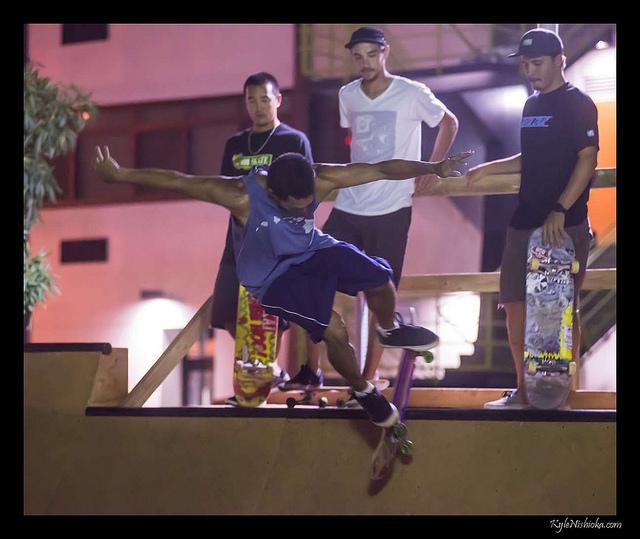What color is the wall?
Keep it brief. White. Is the skateboarder doing the trick coming up or going down?
Be succinct. Down. How many people don't have a skateboard?
Short answer required. 0. Did this happen recently?
Quick response, please. Yes. How many people are shown?
Concise answer only. 4. 